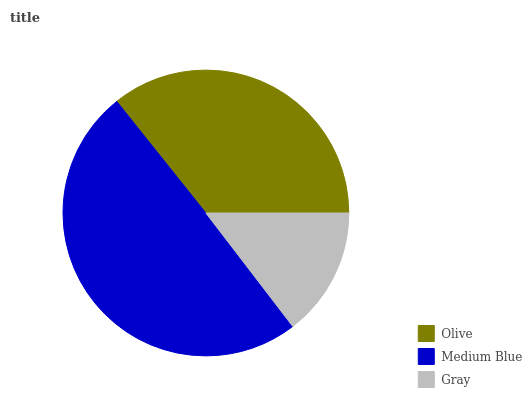Is Gray the minimum?
Answer yes or no. Yes. Is Medium Blue the maximum?
Answer yes or no. Yes. Is Medium Blue the minimum?
Answer yes or no. No. Is Gray the maximum?
Answer yes or no. No. Is Medium Blue greater than Gray?
Answer yes or no. Yes. Is Gray less than Medium Blue?
Answer yes or no. Yes. Is Gray greater than Medium Blue?
Answer yes or no. No. Is Medium Blue less than Gray?
Answer yes or no. No. Is Olive the high median?
Answer yes or no. Yes. Is Olive the low median?
Answer yes or no. Yes. Is Gray the high median?
Answer yes or no. No. Is Medium Blue the low median?
Answer yes or no. No. 